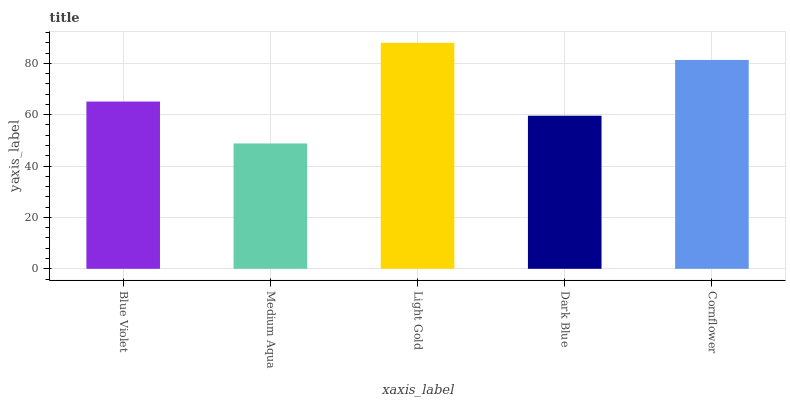Is Medium Aqua the minimum?
Answer yes or no. Yes. Is Light Gold the maximum?
Answer yes or no. Yes. Is Light Gold the minimum?
Answer yes or no. No. Is Medium Aqua the maximum?
Answer yes or no. No. Is Light Gold greater than Medium Aqua?
Answer yes or no. Yes. Is Medium Aqua less than Light Gold?
Answer yes or no. Yes. Is Medium Aqua greater than Light Gold?
Answer yes or no. No. Is Light Gold less than Medium Aqua?
Answer yes or no. No. Is Blue Violet the high median?
Answer yes or no. Yes. Is Blue Violet the low median?
Answer yes or no. Yes. Is Dark Blue the high median?
Answer yes or no. No. Is Light Gold the low median?
Answer yes or no. No. 